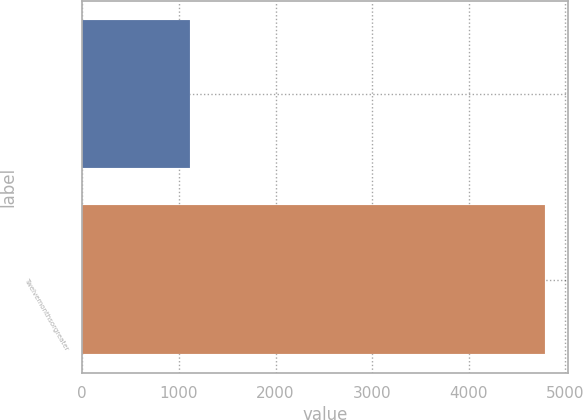Convert chart. <chart><loc_0><loc_0><loc_500><loc_500><bar_chart><ecel><fcel>Twelvemonthsorgreater<nl><fcel>1114.1<fcel>4787<nl></chart> 